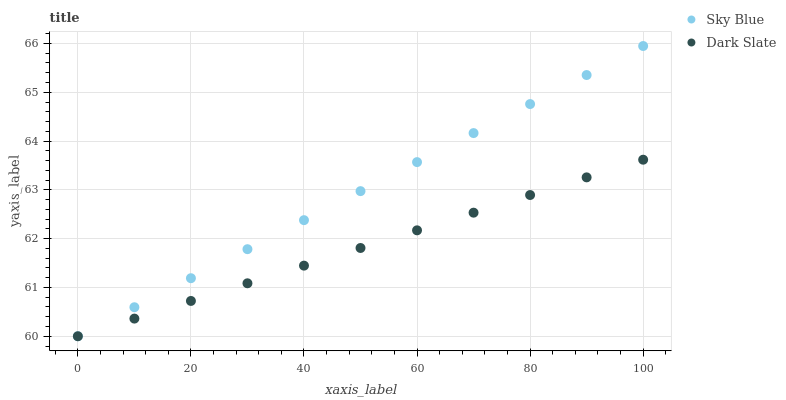Does Dark Slate have the minimum area under the curve?
Answer yes or no. Yes. Does Sky Blue have the maximum area under the curve?
Answer yes or no. Yes. Does Dark Slate have the maximum area under the curve?
Answer yes or no. No. Is Dark Slate the smoothest?
Answer yes or no. Yes. Is Sky Blue the roughest?
Answer yes or no. Yes. Is Dark Slate the roughest?
Answer yes or no. No. Does Sky Blue have the lowest value?
Answer yes or no. Yes. Does Sky Blue have the highest value?
Answer yes or no. Yes. Does Dark Slate have the highest value?
Answer yes or no. No. Does Sky Blue intersect Dark Slate?
Answer yes or no. Yes. Is Sky Blue less than Dark Slate?
Answer yes or no. No. Is Sky Blue greater than Dark Slate?
Answer yes or no. No. 